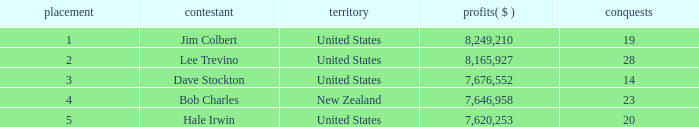How much have players earned with 14 wins ranked below 3? 0.0. Parse the table in full. {'header': ['placement', 'contestant', 'territory', 'profits( $ )', 'conquests'], 'rows': [['1', 'Jim Colbert', 'United States', '8,249,210', '19'], ['2', 'Lee Trevino', 'United States', '8,165,927', '28'], ['3', 'Dave Stockton', 'United States', '7,676,552', '14'], ['4', 'Bob Charles', 'New Zealand', '7,646,958', '23'], ['5', 'Hale Irwin', 'United States', '7,620,253', '20']]} 